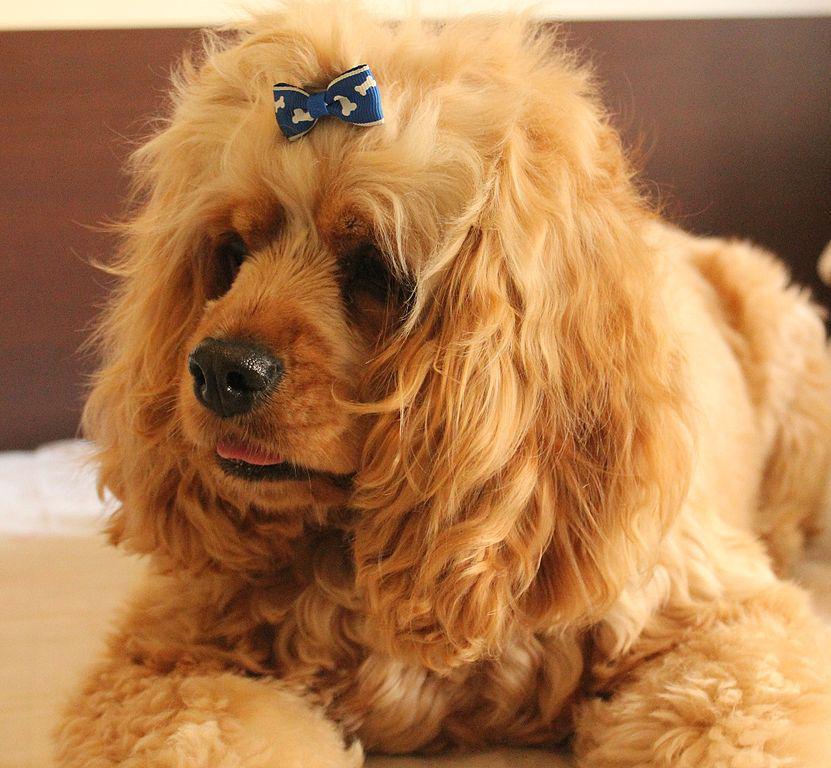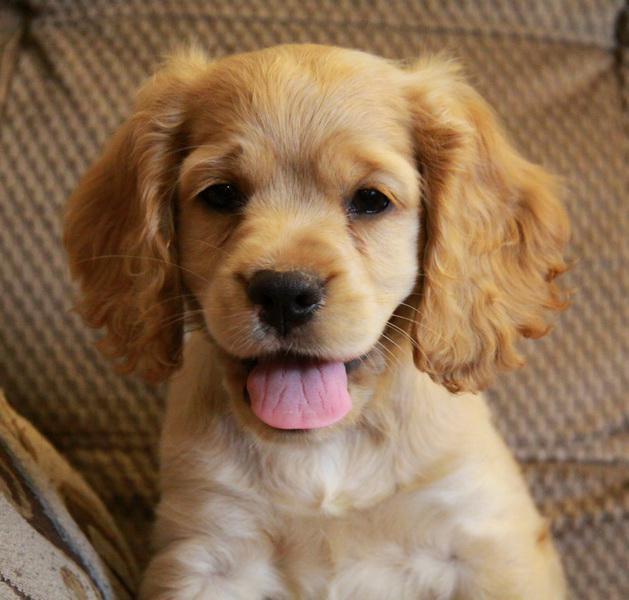The first image is the image on the left, the second image is the image on the right. Examine the images to the left and right. Is the description "The dog in the left image has a hair decoration." accurate? Answer yes or no. Yes. 